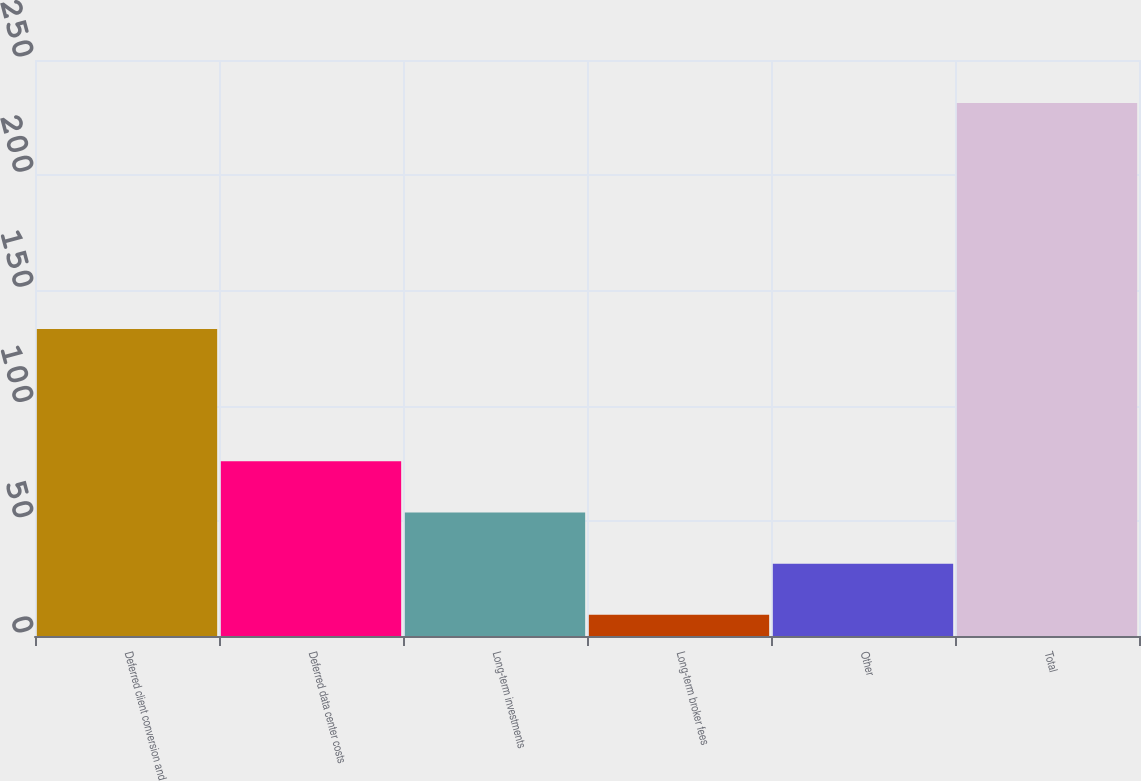<chart> <loc_0><loc_0><loc_500><loc_500><bar_chart><fcel>Deferred client conversion and<fcel>Deferred data center costs<fcel>Long-term investments<fcel>Long-term broker fees<fcel>Other<fcel>Total<nl><fcel>133.3<fcel>75.83<fcel>53.62<fcel>9.2<fcel>31.41<fcel>231.3<nl></chart> 